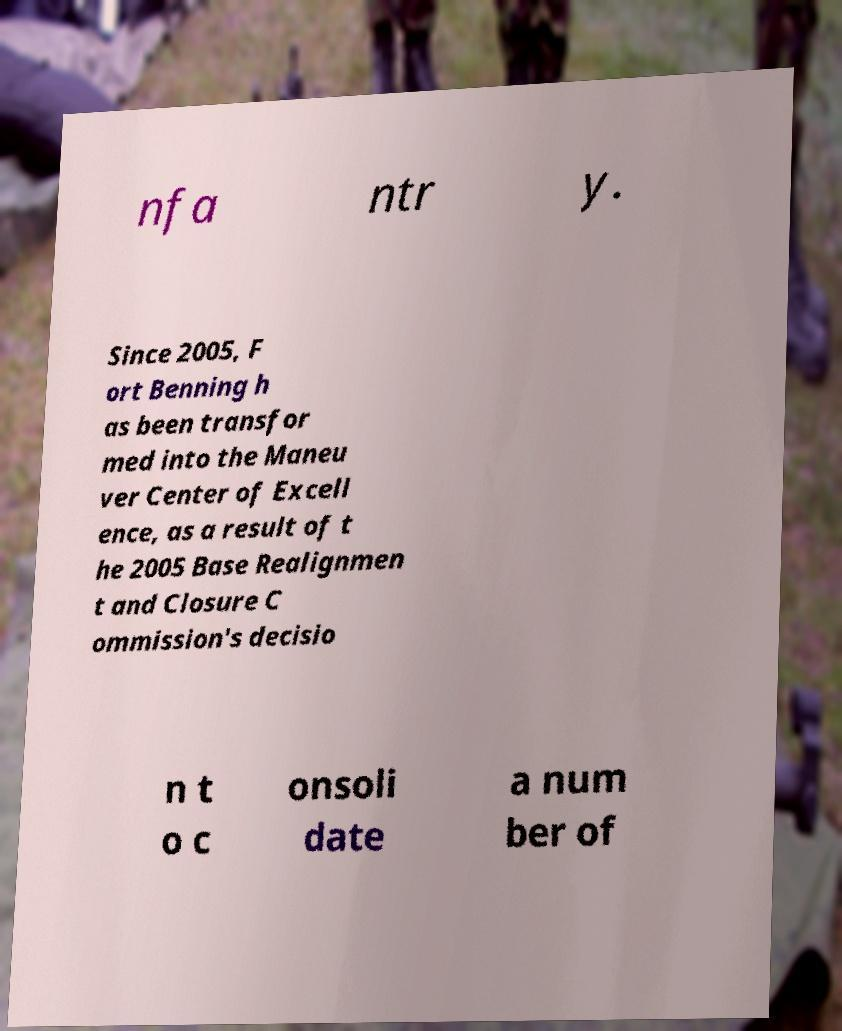There's text embedded in this image that I need extracted. Can you transcribe it verbatim? nfa ntr y. Since 2005, F ort Benning h as been transfor med into the Maneu ver Center of Excell ence, as a result of t he 2005 Base Realignmen t and Closure C ommission's decisio n t o c onsoli date a num ber of 